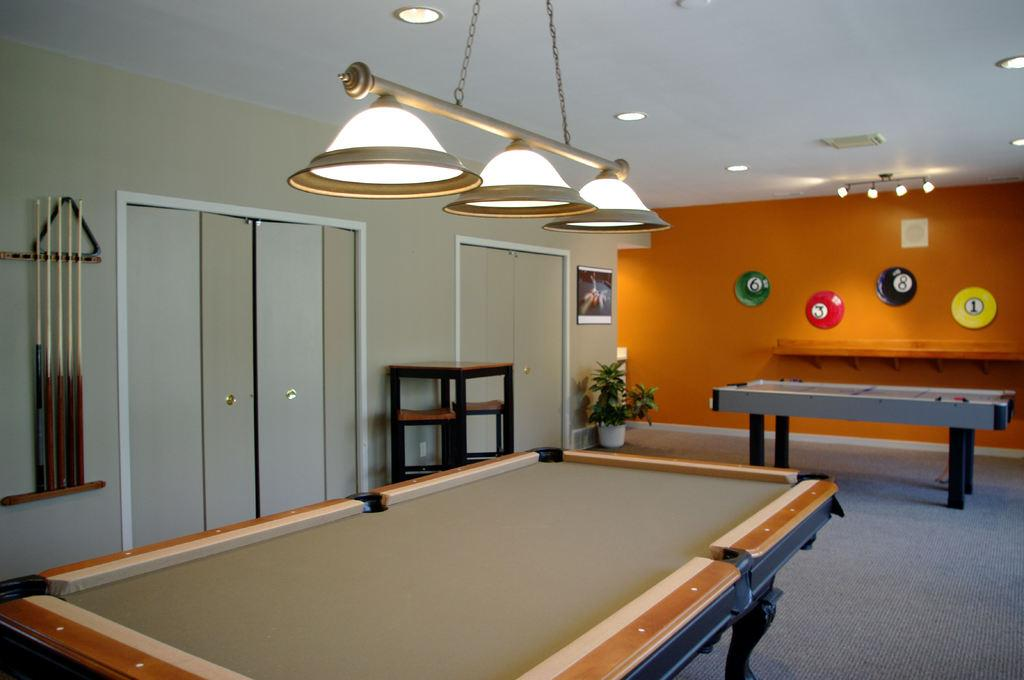What type of table is in the image? There is a snooker table in the image. What color is the wall in the background of the image? There is an orange wall in the background of the image. What is attached to the ceiling in the image? Lights are attached to the ceiling in the image. What type of badge can be seen on the snooker table in the image? There is no badge present on the snooker table in the image. What smell is associated with the image? The image does not convey any specific smell, as it is a visual representation. 